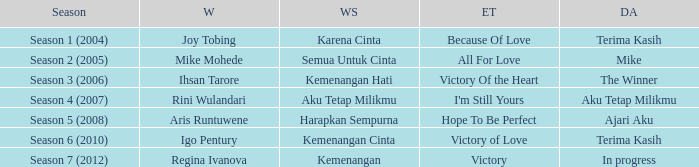Who won with the song kemenangan cinta? Igo Pentury. 